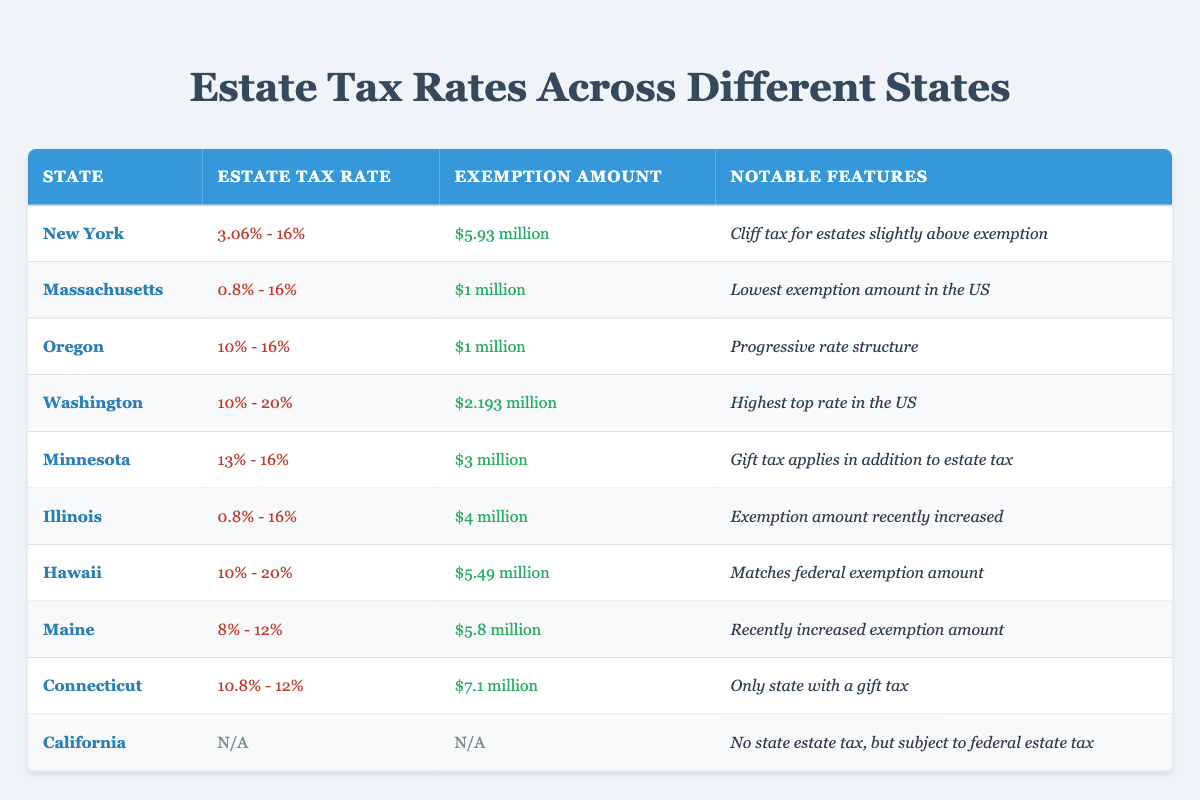What is the exemption amount for Massachusetts? The table specifies that the exemption amount for Massachusetts is $1 million. This information is found directly in the corresponding row for Massachusetts.
Answer: $1 million Which state has the highest estate tax rate? From the table, Washington has the highest estate tax rate ranging from 10% to 20%. This is explicitly stated in its row, and no other state exceeds this range.
Answer: Washington Does California have a state estate tax? The table states that California has "N/A" for both estate tax rate and exemption amount, indicating that there is no state estate tax. This fact can be directly found in the row for California.
Answer: No What is the average exemption amount of the states listed? The exemption amounts for the states are: $5.93 million (New York), $1 million (Massachusetts), $1 million (Oregon), $2.193 million (Washington), $3 million (Minnesota), $4 million (Illinois), $5.49 million (Hawaii), $5.8 million (Maine), $7.1 million (Connecticut). To find the average, add these amounts up: $5.93 million + $1 million + $1 million + $2.193 million + $3 million + $4 million + $5.49 million + $5.8 million + $7.1 million = $31.606 million. There are 9 states, so the average is $31.606 million / 9 = approximately $3.511 million.
Answer: Approximately $3.511 million Which two states have an exemption amount of around $5 million? The states that have exemption amounts close to $5 million are New York with $5.93 million and Maine with $5.8 million. The values can be found directly by examining the exemption amounts in their respective rows.
Answer: New York and Maine 